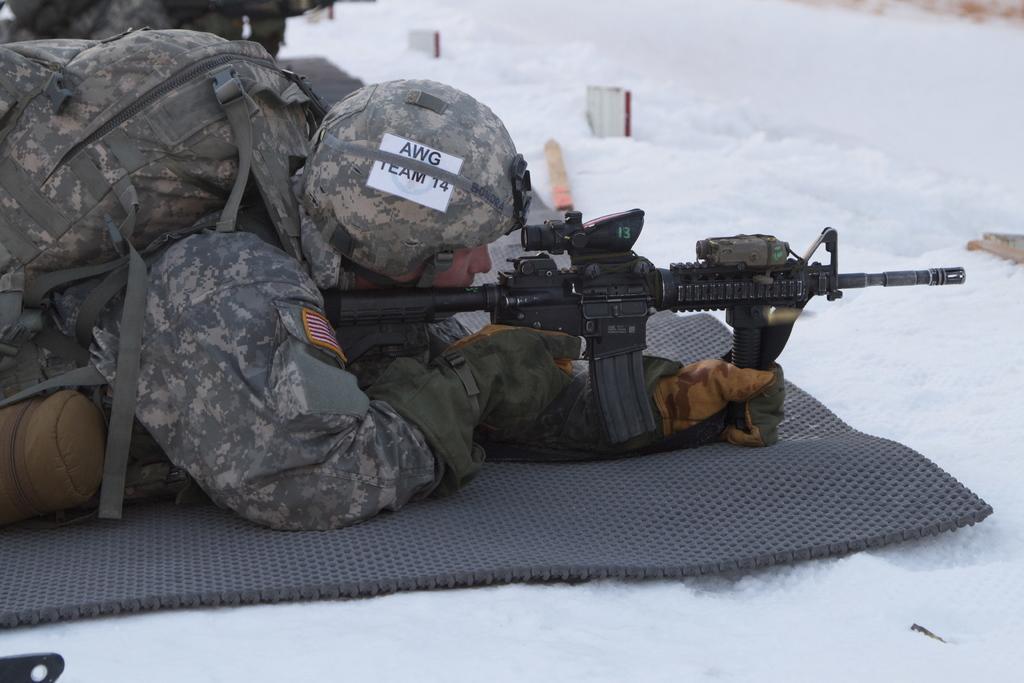How would you summarize this image in a sentence or two? In this picture I can see a man lying on the ground is holding a gun in his hand and a backpack on the back and he wore a helmet on his head and I can see snow on the ground and I can see text on the helmet. 